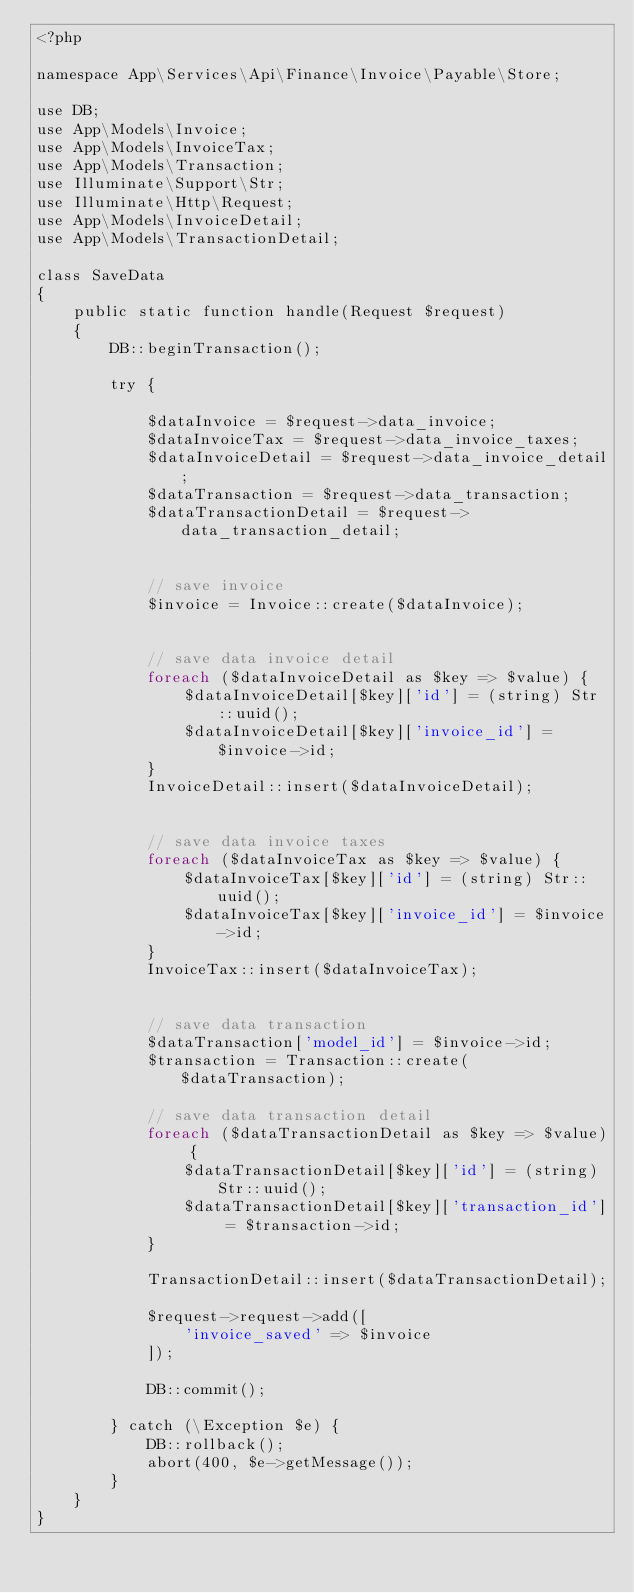Convert code to text. <code><loc_0><loc_0><loc_500><loc_500><_PHP_><?php

namespace App\Services\Api\Finance\Invoice\Payable\Store;

use DB;
use App\Models\Invoice;
use App\Models\InvoiceTax;
use App\Models\Transaction;
use Illuminate\Support\Str;
use Illuminate\Http\Request;
use App\Models\InvoiceDetail;
use App\Models\TransactionDetail;

class SaveData
{
    public static function handle(Request $request)
    {
        DB::beginTransaction();

        try {

            $dataInvoice = $request->data_invoice;
            $dataInvoiceTax = $request->data_invoice_taxes;
            $dataInvoiceDetail = $request->data_invoice_detail;
            $dataTransaction = $request->data_transaction;
            $dataTransactionDetail = $request->data_transaction_detail;


            // save invoice
            $invoice = Invoice::create($dataInvoice);

            
            // save data invoice detail
            foreach ($dataInvoiceDetail as $key => $value) {
                $dataInvoiceDetail[$key]['id'] = (string) Str::uuid();
                $dataInvoiceDetail[$key]['invoice_id'] = $invoice->id;
            }
            InvoiceDetail::insert($dataInvoiceDetail);

            
            // save data invoice taxes
            foreach ($dataInvoiceTax as $key => $value) {
                $dataInvoiceTax[$key]['id'] = (string) Str::uuid();
                $dataInvoiceTax[$key]['invoice_id'] = $invoice->id;
            }
            InvoiceTax::insert($dataInvoiceTax);


            // save data transaction
            $dataTransaction['model_id'] = $invoice->id;
            $transaction = Transaction::create($dataTransaction);
            
            // save data transaction detail
            foreach ($dataTransactionDetail as $key => $value) {
                $dataTransactionDetail[$key]['id'] = (string) Str::uuid();
                $dataTransactionDetail[$key]['transaction_id'] = $transaction->id;
            }

            TransactionDetail::insert($dataTransactionDetail);

            $request->request->add([
                'invoice_saved' => $invoice
            ]);
            
            DB::commit();

        } catch (\Exception $e) {
            DB::rollback();
            abort(400, $e->getMessage());
        }
    }
}
</code> 